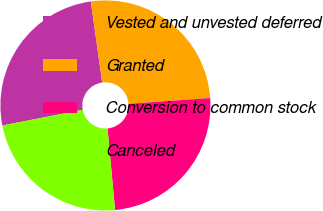Convert chart. <chart><loc_0><loc_0><loc_500><loc_500><pie_chart><fcel>Vested and unvested deferred<fcel>Granted<fcel>Conversion to common stock<fcel>Canceled<nl><fcel>25.84%<fcel>26.1%<fcel>24.66%<fcel>23.4%<nl></chart> 